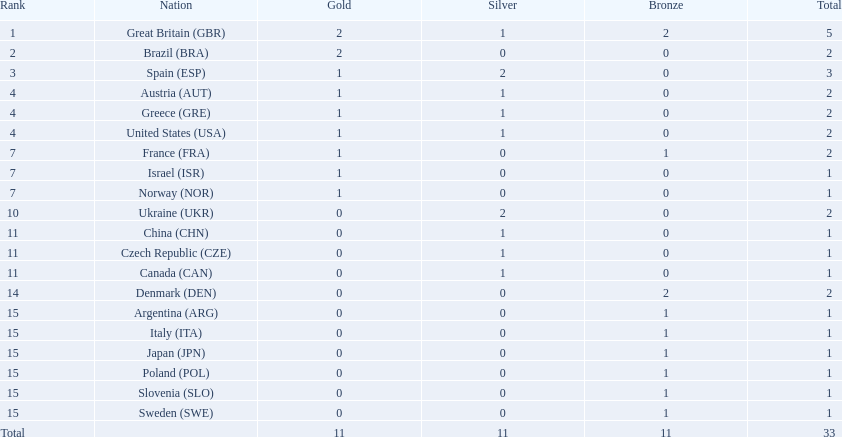What are all the nations? Great Britain (GBR), Brazil (BRA), Spain (ESP), Austria (AUT), Greece (GRE), United States (USA), France (FRA), Israel (ISR), Norway (NOR), Ukraine (UKR), China (CHN), Czech Republic (CZE), Canada (CAN), Denmark (DEN), Argentina (ARG), Italy (ITA), Japan (JPN), Poland (POL), Slovenia (SLO), Sweden (SWE). Which ones obtained a medal? Great Britain (GBR), Brazil (BRA), Spain (ESP), Austria (AUT), Greece (GRE), United States (USA), France (FRA), Israel (ISR), Norway (NOR), Ukraine (UKR), China (CHN), Czech Republic (CZE), Canada (CAN), Denmark (DEN), Argentina (ARG), Italy (ITA), Japan (JPN), Poland (POL), Slovenia (SLO), Sweden (SWE). Which nations gained a minimum of 3 medals? Great Britain (GBR), Spain (ESP). Which nation secured 3 medals? Spain (ESP). 